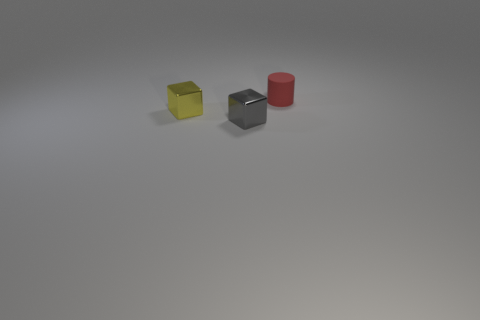There is a thing that is behind the tiny gray object and to the right of the yellow block; what is its shape?
Offer a terse response. Cylinder. What is the material of the block to the right of the small cube that is behind the small gray cube?
Offer a very short reply. Metal. Are the cube behind the small gray shiny thing and the red thing made of the same material?
Offer a terse response. No. What is the size of the red thing that is behind the small yellow thing?
Make the answer very short. Small. There is a thing that is right of the gray metal cube; are there any small gray metal things behind it?
Offer a terse response. No. The rubber object is what color?
Give a very brief answer. Red. The object that is both behind the gray block and right of the tiny yellow block is what color?
Keep it short and to the point. Red. Do the rubber object behind the gray metallic cube and the gray cube have the same size?
Your response must be concise. Yes. Is the number of shiny blocks in front of the red rubber object greater than the number of large gray cylinders?
Give a very brief answer. Yes. Does the small matte object have the same shape as the gray metal object?
Offer a terse response. No. 